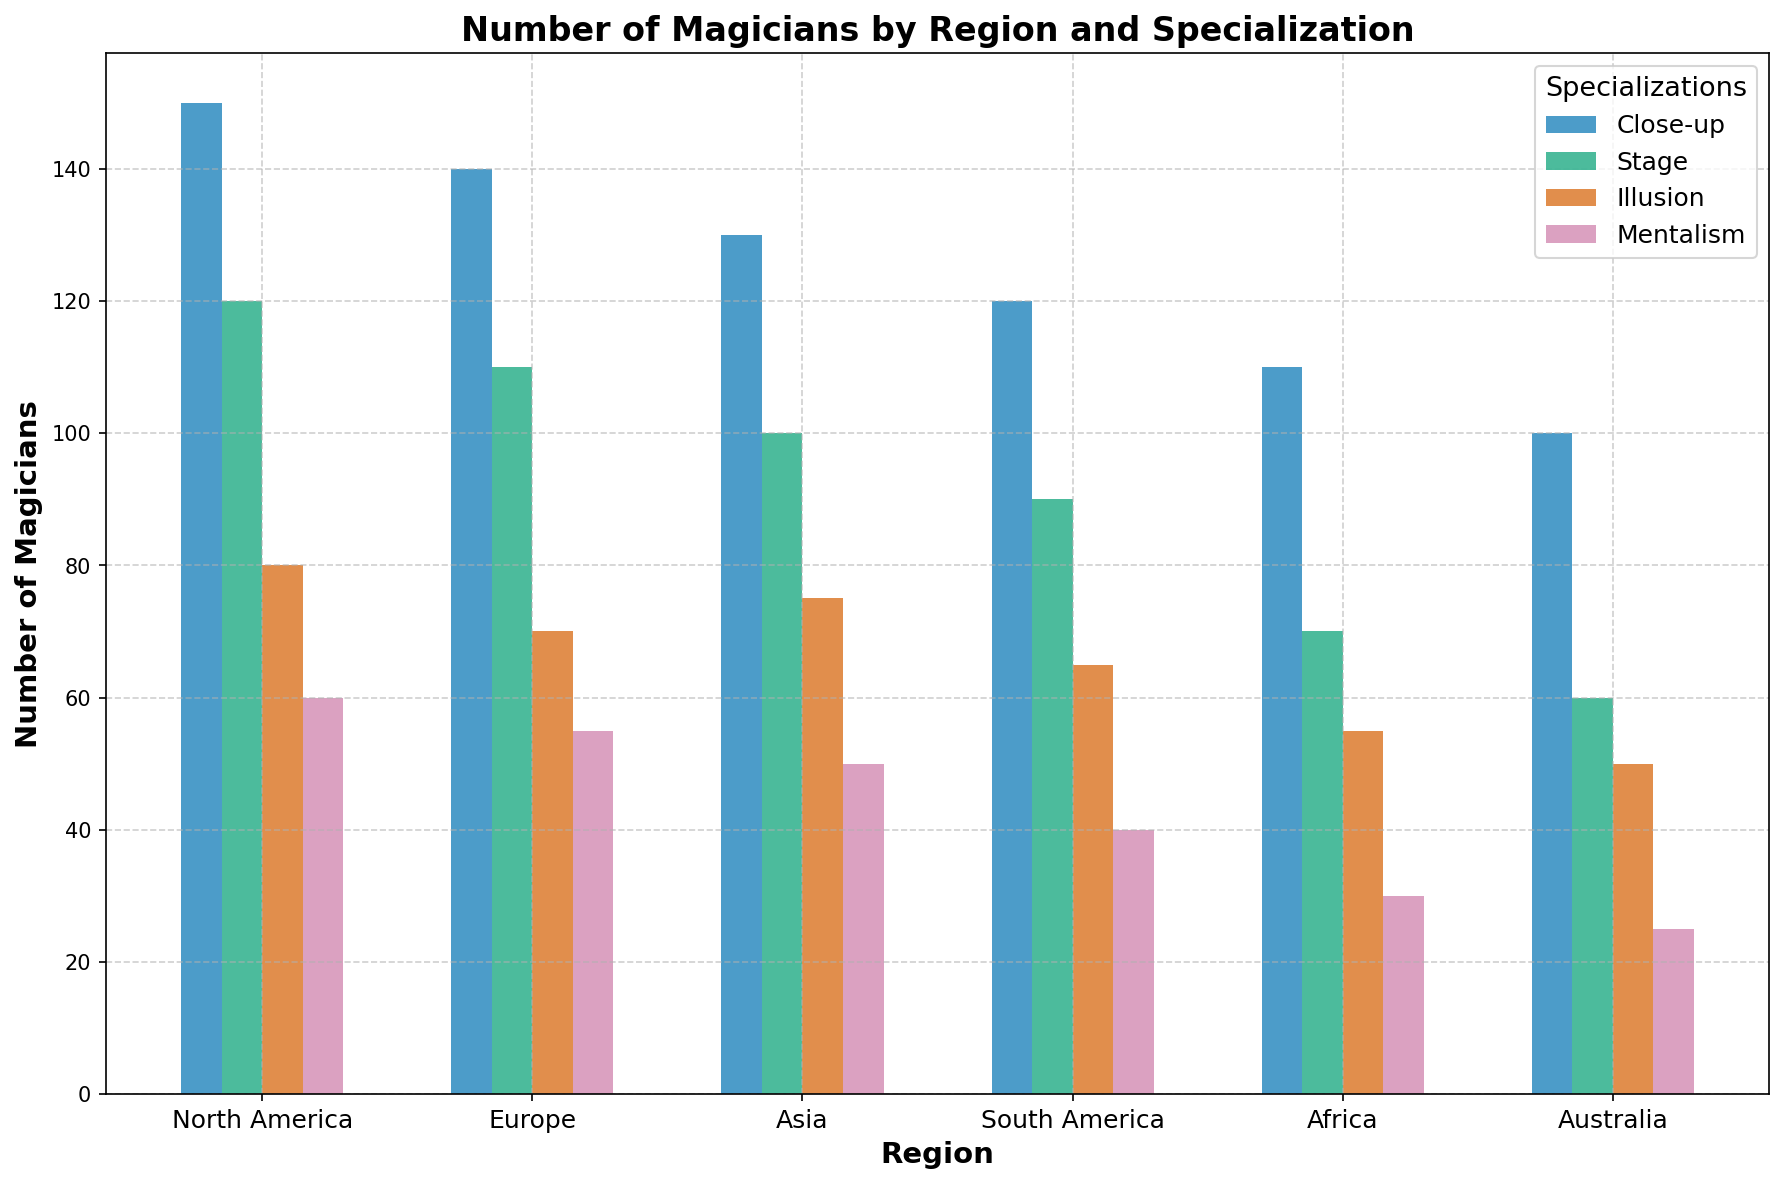How many more Close-up magicians are there in North America than in Australia? In North America, the number of Close-up magicians is 150, while in Australia, it is 100. To find the difference: 150 - 100 = 50.
Answer: 50 Which region has the highest number of Mentalism magicians, and what is that number? By comparing the heights of the Mentalism bars, North America has the highest number with 60 Mentalism magicians.
Answer: North America, 60 How many total magicians are in Asia across all specializations? Add the number of magicians in each specialization in Asia: Close-up (130) + Stage (100) + Illusion (75) + Mentalism (50) = 355
Answer: 355 What is the total number of Stage magicians in all regions combined? Sum the number of Stage magicians in each region: North America (120) + Europe (110) + Asia (100) + South America (90) + Africa (70) + Australia (60) = 550
Answer: 550 Which specialization has the least number of magicians in Africa, and how many are there? By observing the bar heights for Africa, Mentalism has the least number of magicians, with 30.
Answer: Mentalism, 30 Which region has the smallest variance in the number of magicians across all specializations? Calculate the variances for each region. The region with the smallest spread/variance is Europe, with counts (140, 110, 70, 55): Variance calculation yields lower variance than other regions.
Answer: Europe Order the regions by their total number of Illusion magicians from highest to lowest. Compare the number of Illusion magicians in each region: North America (80), Asia (75), Europe (70), South America (65), Australia (50), Africa (55). Order: North America, Asia, Europe, South America, Africa, Australia.
Answer: North America, Asia, Europe, South America, Africa, Australia What is the average number of magicians specializing in Stage magic across North America and Europe? The number of Stage magicians in North America is 120, and in Europe, it is 110. The average is calculated as (120 + 110) / 2 = 115.
Answer: 115 Compare the total number of Close-up and Stage magicians in South America. Are there more Close-up or Stage magicians? The number of Close-up magicians in South America is 120, and the number of Stage magicians is 90. 120 is greater than 90, so there are more Close-up magicians.
Answer: Close-up magicians What is the range of the number of magicians specializing in Illusion across all regions? Determine the highest and lowest values for Illusion magicians: Highest is North America (80), and lowest is Australia (50). The range is 80 - 50 = 30.
Answer: 30 